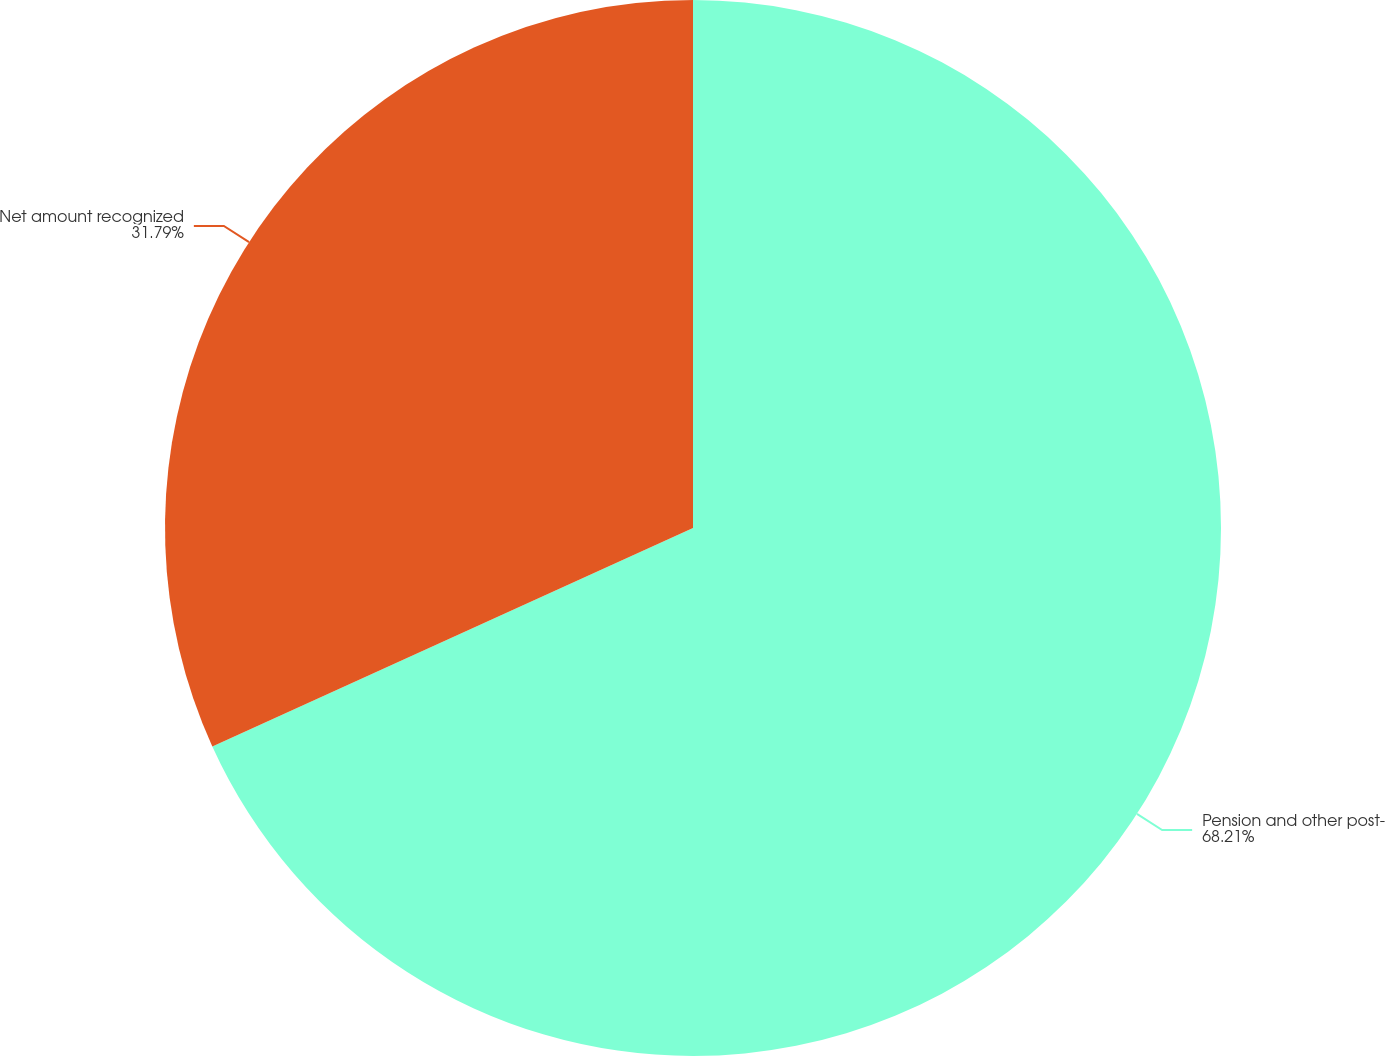Convert chart. <chart><loc_0><loc_0><loc_500><loc_500><pie_chart><fcel>Pension and other post-<fcel>Net amount recognized<nl><fcel>68.21%<fcel>31.79%<nl></chart> 